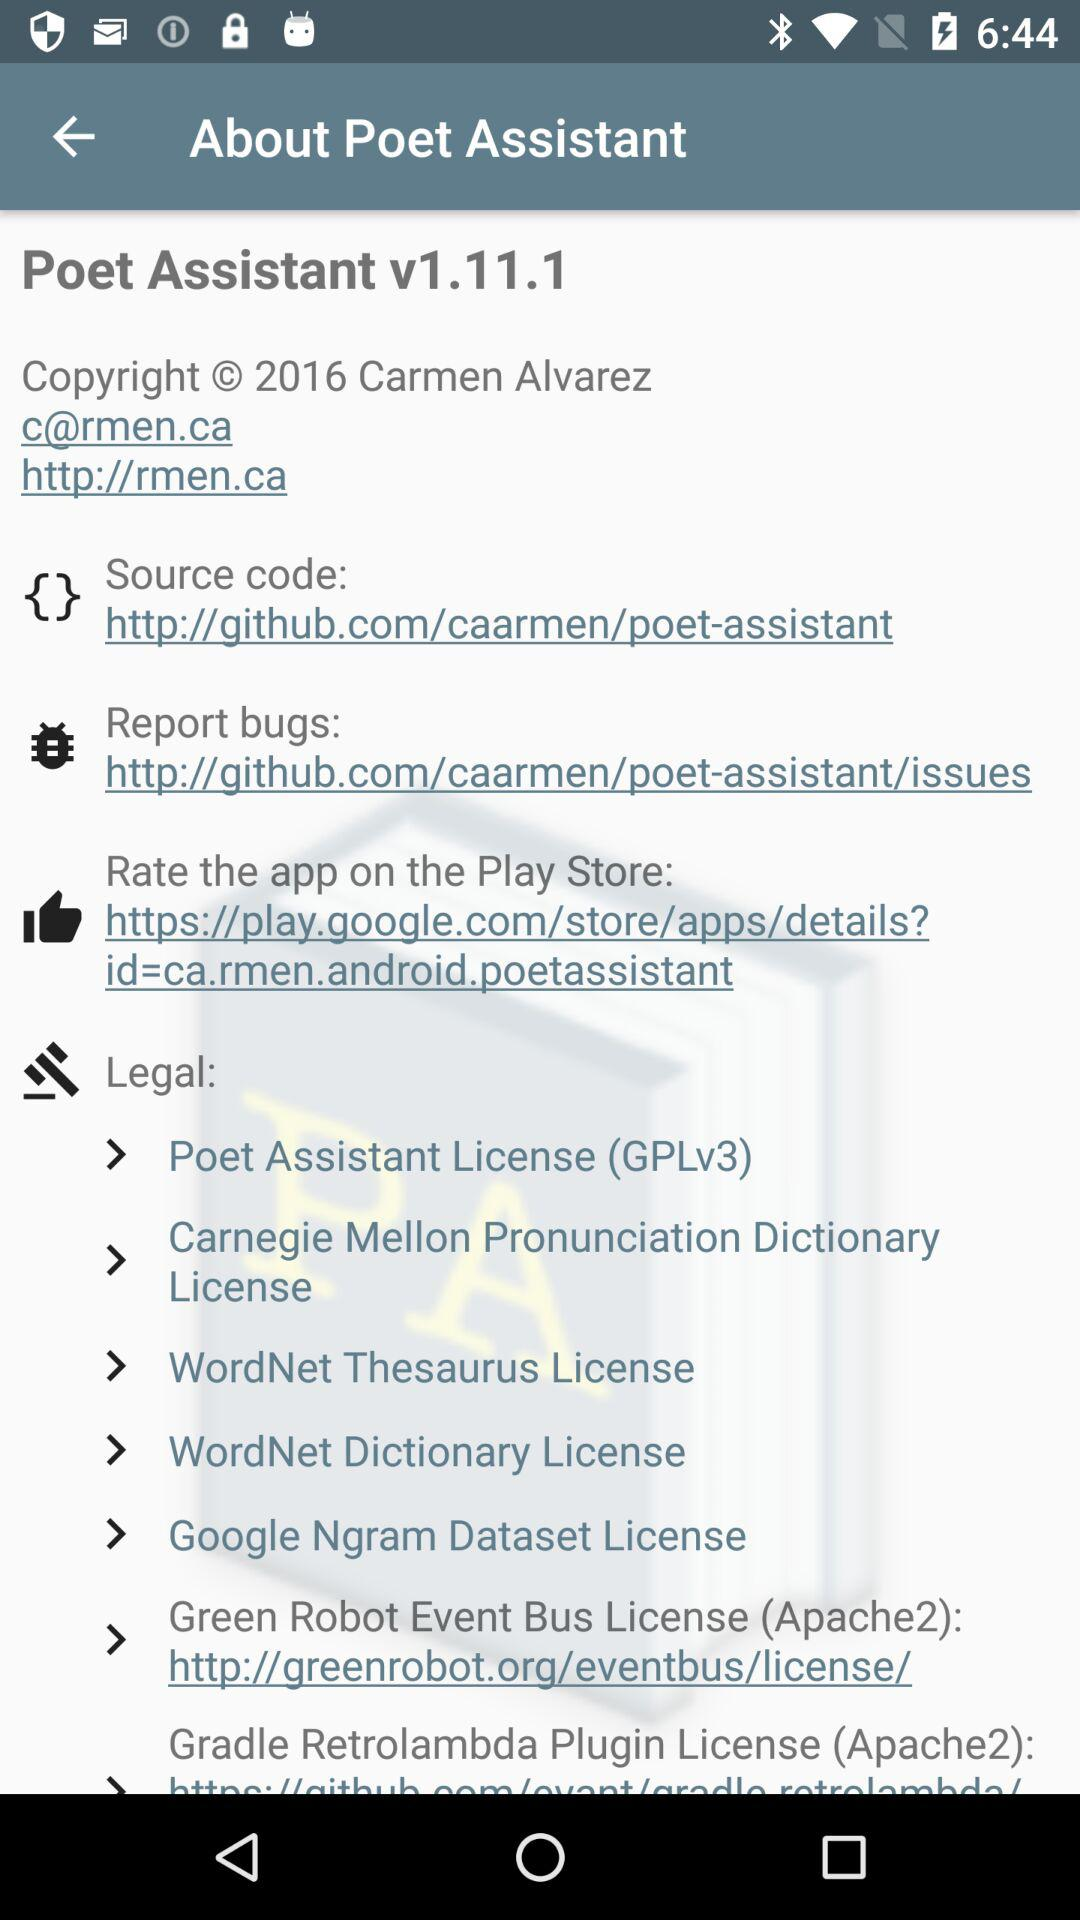What is the version given on the screen? The given version is v1.11.1. 